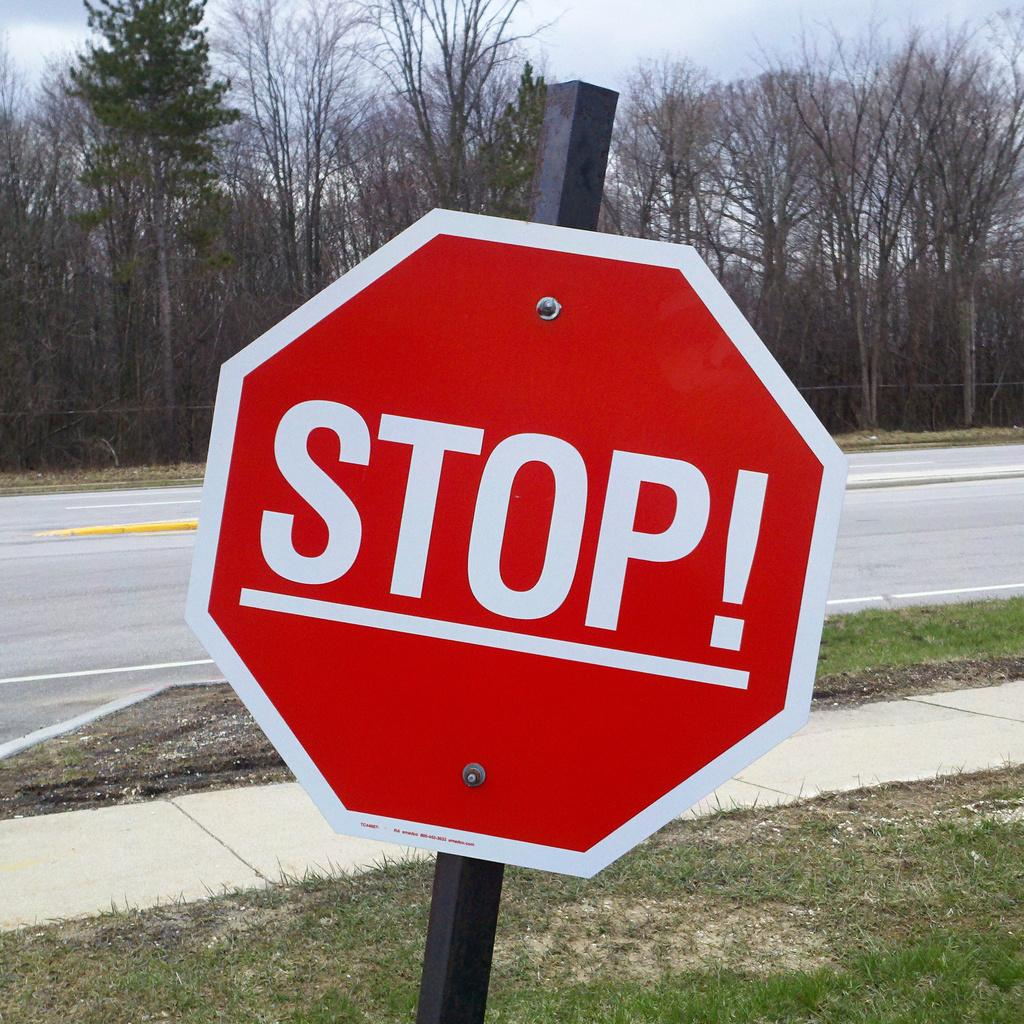<image>
Offer a succinct explanation of the picture presented. A red street sign that says Stop is tilted at an angle. 